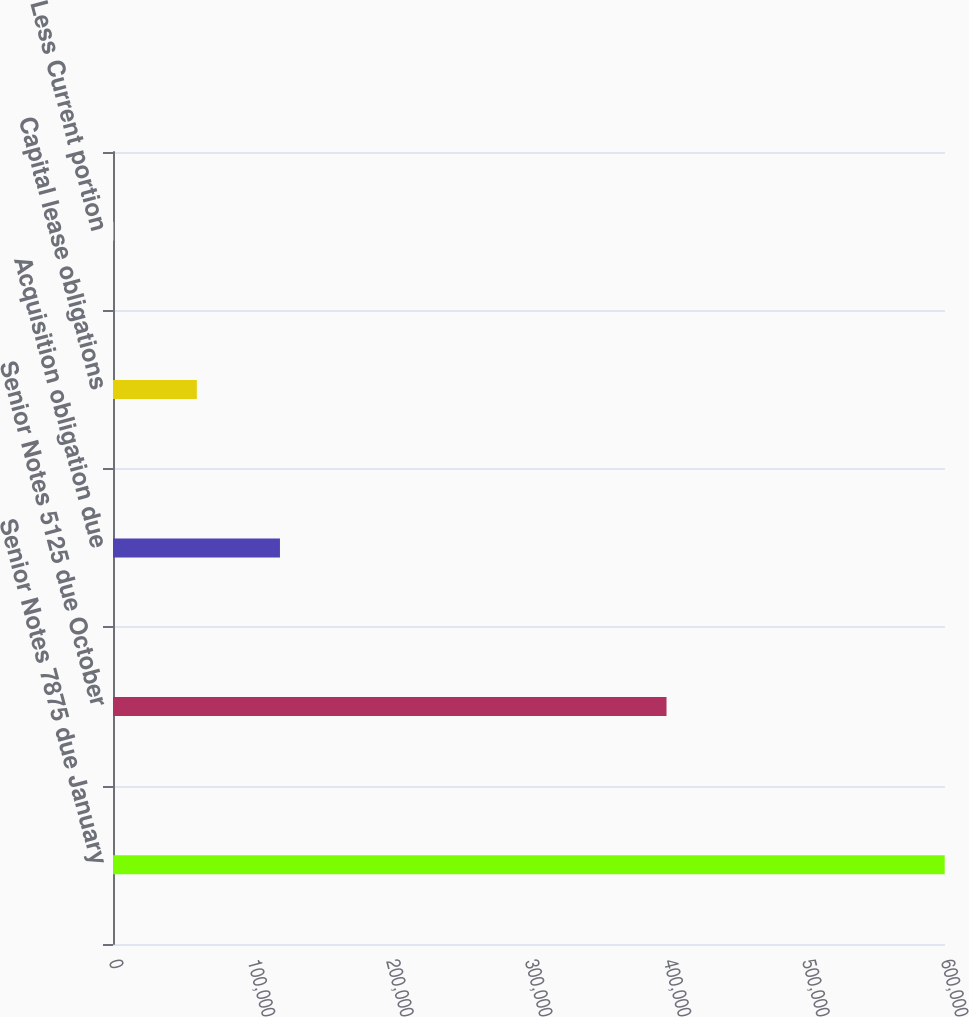<chart> <loc_0><loc_0><loc_500><loc_500><bar_chart><fcel>Senior Notes 7875 due January<fcel>Senior Notes 5125 due October<fcel>Acquisition obligation due<fcel>Capital lease obligations<fcel>Less Current portion<nl><fcel>599788<fcel>399177<fcel>120403<fcel>60480.1<fcel>557<nl></chart> 